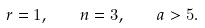<formula> <loc_0><loc_0><loc_500><loc_500>r = 1 , \quad n = 3 , \quad a > 5 .</formula> 